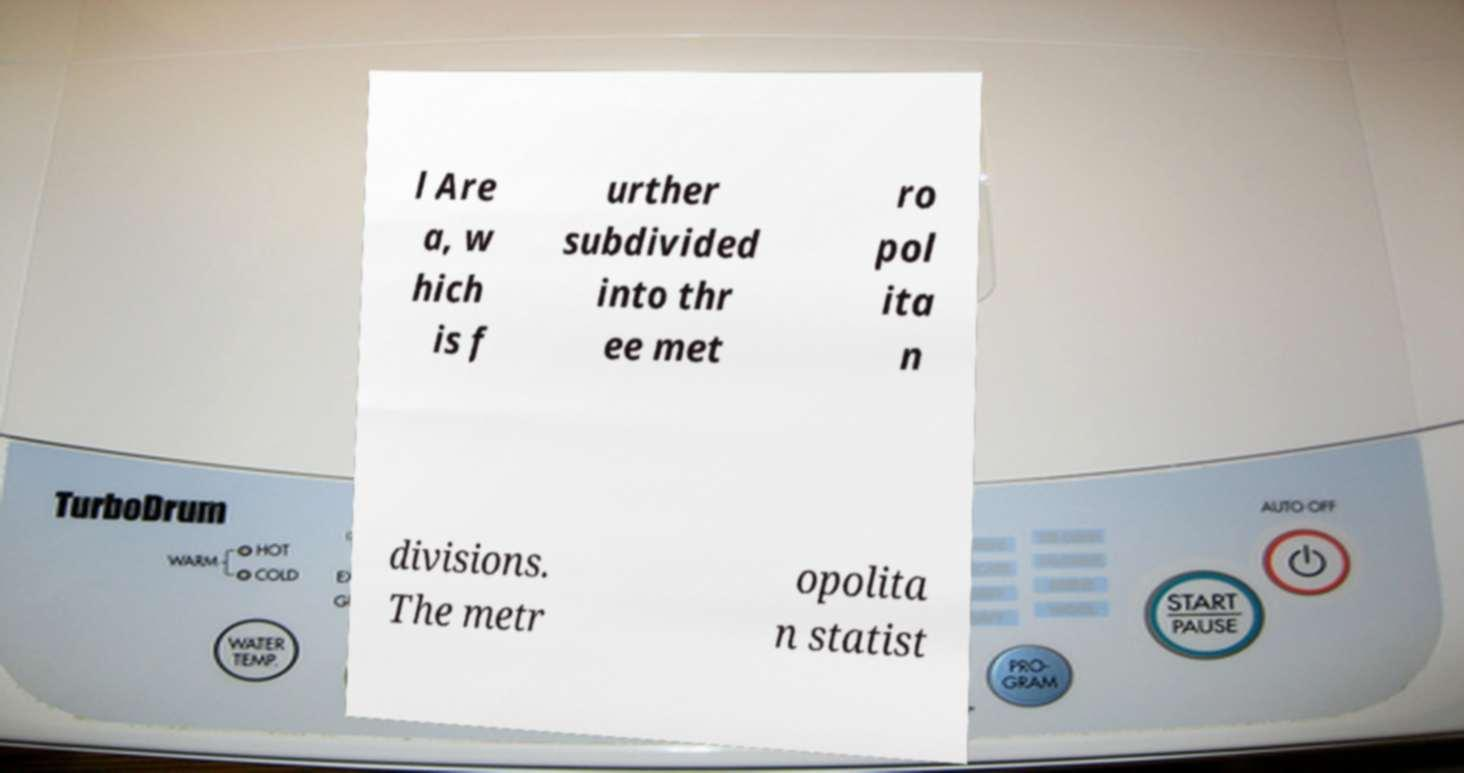Can you read and provide the text displayed in the image?This photo seems to have some interesting text. Can you extract and type it out for me? l Are a, w hich is f urther subdivided into thr ee met ro pol ita n divisions. The metr opolita n statist 